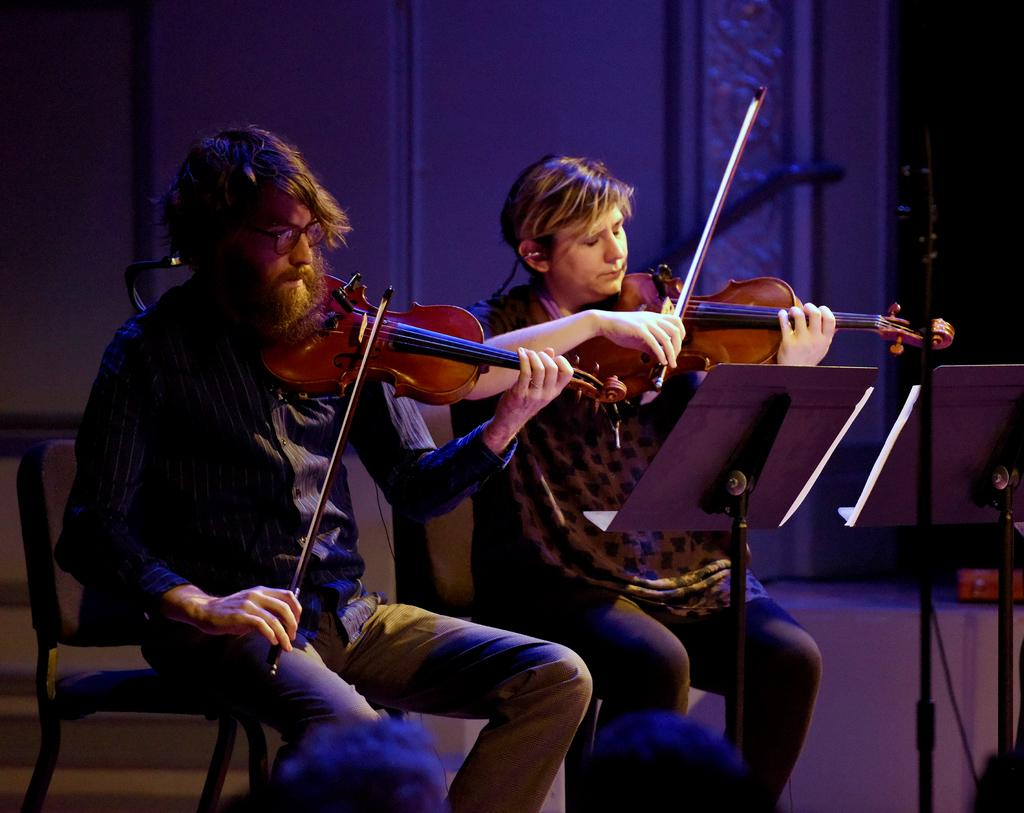Who are the people in the image? There is a man and a woman in the image. What are the man and woman doing in the image? They are sitting on chairs and playing violins. What can be seen on the right side of the image? There are two strands on the right side of the image. What is visible in the background of the image? There is a wall in the background of the image. What type of current is flowing through the van in the image? There is no van present in the image, and therefore no current can be observed. What discovery was made by the man and woman in the image? There is no indication of a discovery being made in the image; they are simply playing violins. 